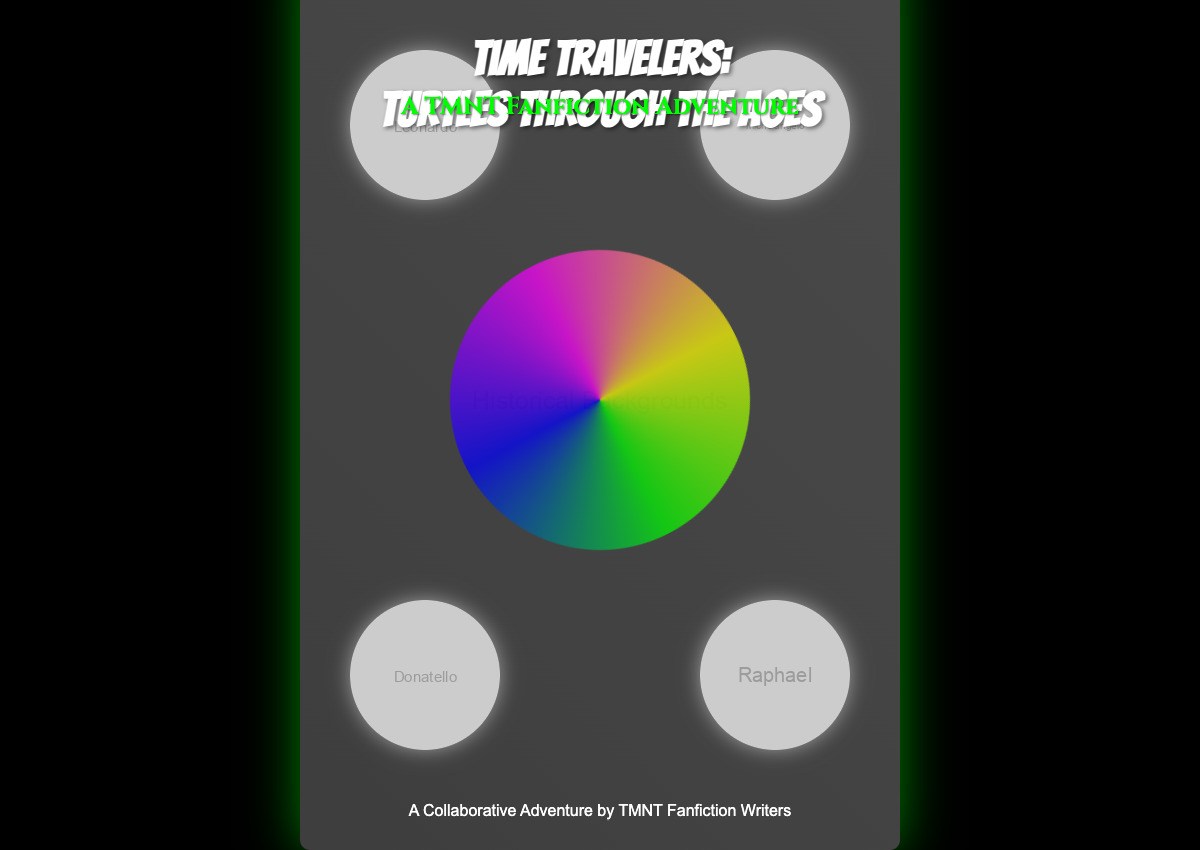What is the title of the book? The title of the book is prominently displayed in the center of the cover.
Answer: Time Travelers: Turtles Through the Ages Who are the main characters featured on the cover? The characters are represented by images in specific sections of the cover.
Answer: Leonardo, Michelangelo, Donatello, Raphael What color is the vortex at the center of the cover? The vortex has a conic gradient including several colors.
Answer: Green, blue, magenta, yellow What is the subtitle of the book? The subtitle is located just below the main title on the cover.
Answer: A TMNT Fanfiction Adventure What is the genre of the book? The genre is indicated by the subtitle, suggesting the type of narrative.
Answer: Fanfiction How many turtles are depicted? The number of turtles can be counted from their representations on the cover.
Answer: Four What is the primary background color of the book cover? The background of the cover uses specific shades described in the design.
Answer: Black What is the author line at the bottom of the cover? The author line identifies the creators of the book.
Answer: A Collaborative Adventure by TMNT Fanfiction Writers What kind of animation effect is applied to the vortex? The animation description details the movement of the vortex.
Answer: Spin What font is used for the title? The title features a specific font style that stands out on the cover.
Answer: Bangers 